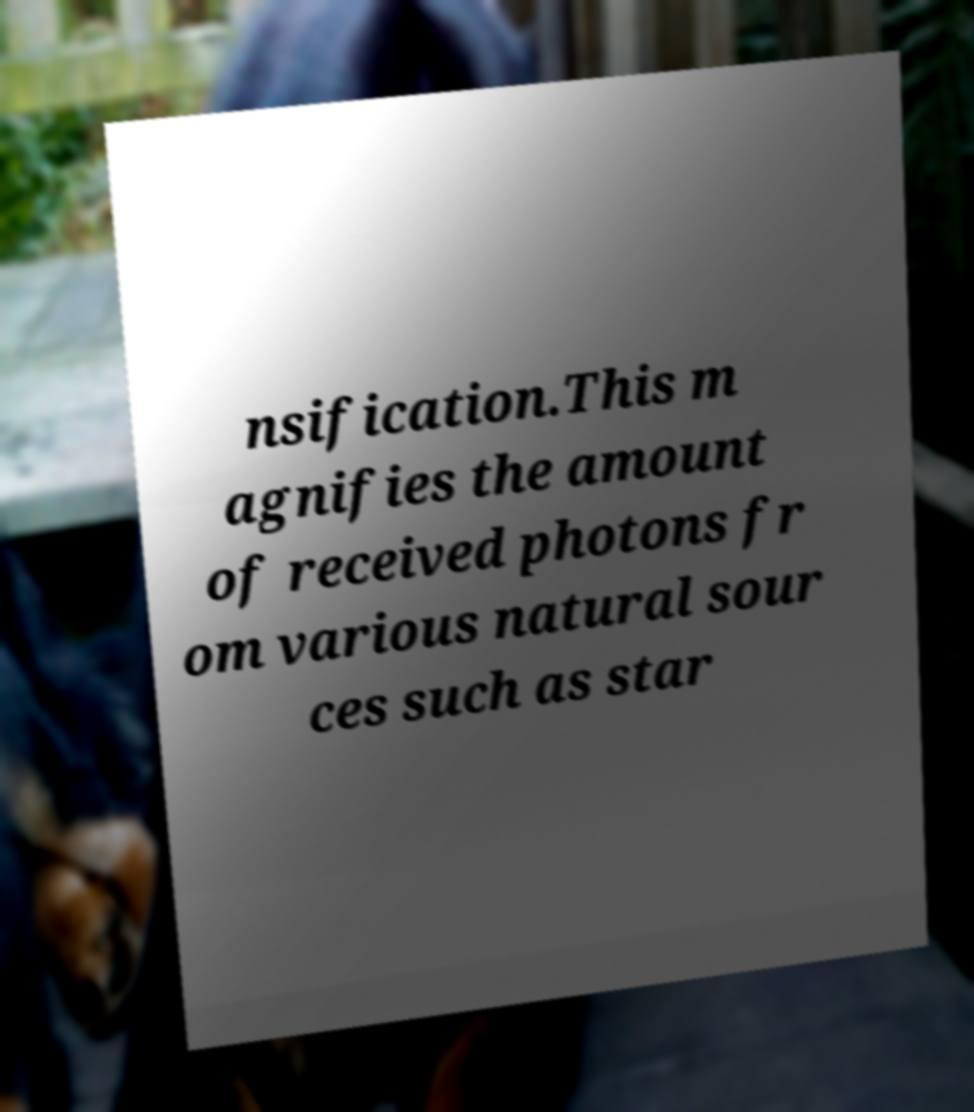Can you accurately transcribe the text from the provided image for me? nsification.This m agnifies the amount of received photons fr om various natural sour ces such as star 